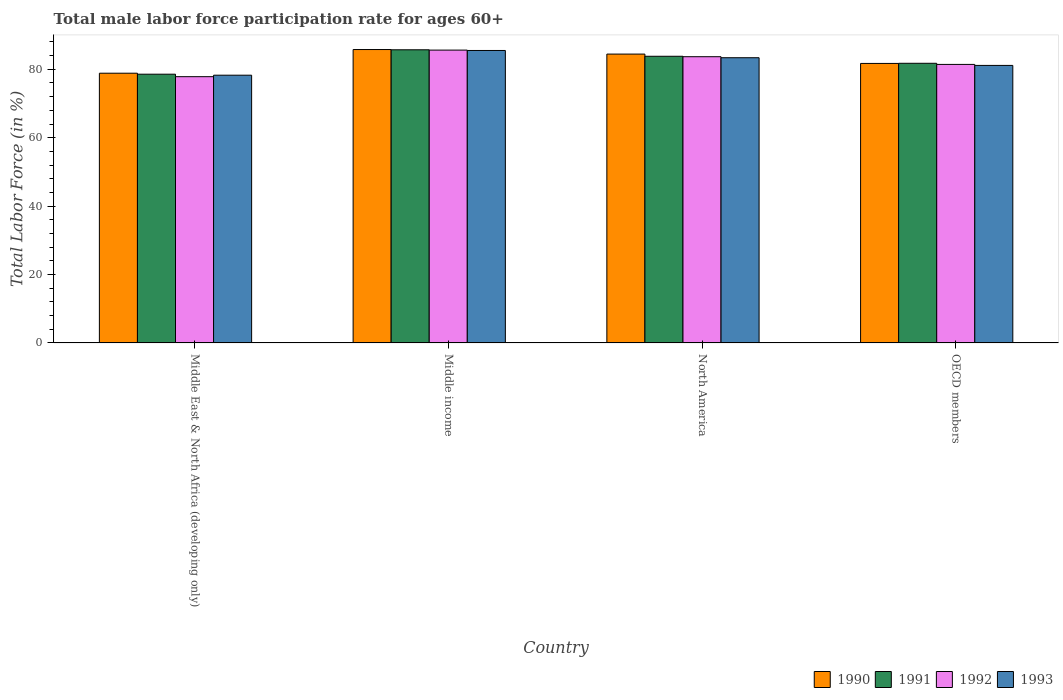How many different coloured bars are there?
Make the answer very short. 4. How many groups of bars are there?
Your answer should be compact. 4. Are the number of bars on each tick of the X-axis equal?
Give a very brief answer. Yes. How many bars are there on the 2nd tick from the left?
Give a very brief answer. 4. What is the male labor force participation rate in 1993 in Middle income?
Offer a terse response. 85.5. Across all countries, what is the maximum male labor force participation rate in 1990?
Keep it short and to the point. 85.78. Across all countries, what is the minimum male labor force participation rate in 1990?
Your answer should be very brief. 78.86. In which country was the male labor force participation rate in 1990 maximum?
Provide a short and direct response. Middle income. In which country was the male labor force participation rate in 1990 minimum?
Ensure brevity in your answer.  Middle East & North Africa (developing only). What is the total male labor force participation rate in 1993 in the graph?
Keep it short and to the point. 328.31. What is the difference between the male labor force participation rate in 1990 in Middle income and that in OECD members?
Your answer should be very brief. 4.06. What is the difference between the male labor force participation rate in 1990 in North America and the male labor force participation rate in 1992 in Middle East & North Africa (developing only)?
Your answer should be compact. 6.61. What is the average male labor force participation rate in 1992 per country?
Your response must be concise. 82.14. What is the difference between the male labor force participation rate of/in 1991 and male labor force participation rate of/in 1993 in North America?
Provide a short and direct response. 0.42. What is the ratio of the male labor force participation rate in 1990 in Middle income to that in OECD members?
Your answer should be compact. 1.05. What is the difference between the highest and the second highest male labor force participation rate in 1990?
Your answer should be compact. -2.73. What is the difference between the highest and the lowest male labor force participation rate in 1992?
Offer a terse response. 7.77. Is the sum of the male labor force participation rate in 1990 in North America and OECD members greater than the maximum male labor force participation rate in 1992 across all countries?
Give a very brief answer. Yes. How many bars are there?
Ensure brevity in your answer.  16. How many countries are there in the graph?
Offer a terse response. 4. What is the difference between two consecutive major ticks on the Y-axis?
Your answer should be compact. 20. Are the values on the major ticks of Y-axis written in scientific E-notation?
Offer a very short reply. No. Does the graph contain any zero values?
Your answer should be compact. No. Where does the legend appear in the graph?
Your response must be concise. Bottom right. How many legend labels are there?
Make the answer very short. 4. How are the legend labels stacked?
Your response must be concise. Horizontal. What is the title of the graph?
Your answer should be very brief. Total male labor force participation rate for ages 60+. What is the Total Labor Force (in %) in 1990 in Middle East & North Africa (developing only)?
Your answer should be very brief. 78.86. What is the Total Labor Force (in %) of 1991 in Middle East & North Africa (developing only)?
Offer a very short reply. 78.57. What is the Total Labor Force (in %) of 1992 in Middle East & North Africa (developing only)?
Provide a succinct answer. 77.85. What is the Total Labor Force (in %) of 1993 in Middle East & North Africa (developing only)?
Offer a very short reply. 78.28. What is the Total Labor Force (in %) in 1990 in Middle income?
Your answer should be very brief. 85.78. What is the Total Labor Force (in %) in 1991 in Middle income?
Give a very brief answer. 85.71. What is the Total Labor Force (in %) of 1992 in Middle income?
Offer a terse response. 85.62. What is the Total Labor Force (in %) in 1993 in Middle income?
Your answer should be compact. 85.5. What is the Total Labor Force (in %) in 1990 in North America?
Give a very brief answer. 84.45. What is the Total Labor Force (in %) of 1991 in North America?
Make the answer very short. 83.81. What is the Total Labor Force (in %) in 1992 in North America?
Offer a terse response. 83.69. What is the Total Labor Force (in %) of 1993 in North America?
Your answer should be very brief. 83.39. What is the Total Labor Force (in %) of 1990 in OECD members?
Provide a succinct answer. 81.72. What is the Total Labor Force (in %) in 1991 in OECD members?
Provide a succinct answer. 81.76. What is the Total Labor Force (in %) of 1992 in OECD members?
Ensure brevity in your answer.  81.43. What is the Total Labor Force (in %) in 1993 in OECD members?
Provide a succinct answer. 81.14. Across all countries, what is the maximum Total Labor Force (in %) in 1990?
Your answer should be compact. 85.78. Across all countries, what is the maximum Total Labor Force (in %) in 1991?
Your response must be concise. 85.71. Across all countries, what is the maximum Total Labor Force (in %) of 1992?
Your answer should be very brief. 85.62. Across all countries, what is the maximum Total Labor Force (in %) in 1993?
Your answer should be very brief. 85.5. Across all countries, what is the minimum Total Labor Force (in %) of 1990?
Offer a very short reply. 78.86. Across all countries, what is the minimum Total Labor Force (in %) in 1991?
Offer a terse response. 78.57. Across all countries, what is the minimum Total Labor Force (in %) in 1992?
Your response must be concise. 77.85. Across all countries, what is the minimum Total Labor Force (in %) of 1993?
Your response must be concise. 78.28. What is the total Total Labor Force (in %) in 1990 in the graph?
Provide a short and direct response. 330.81. What is the total Total Labor Force (in %) in 1991 in the graph?
Provide a short and direct response. 329.85. What is the total Total Labor Force (in %) of 1992 in the graph?
Your answer should be very brief. 328.58. What is the total Total Labor Force (in %) of 1993 in the graph?
Give a very brief answer. 328.31. What is the difference between the Total Labor Force (in %) of 1990 in Middle East & North Africa (developing only) and that in Middle income?
Your answer should be compact. -6.92. What is the difference between the Total Labor Force (in %) in 1991 in Middle East & North Africa (developing only) and that in Middle income?
Provide a succinct answer. -7.13. What is the difference between the Total Labor Force (in %) in 1992 in Middle East & North Africa (developing only) and that in Middle income?
Provide a short and direct response. -7.77. What is the difference between the Total Labor Force (in %) in 1993 in Middle East & North Africa (developing only) and that in Middle income?
Provide a succinct answer. -7.23. What is the difference between the Total Labor Force (in %) of 1990 in Middle East & North Africa (developing only) and that in North America?
Offer a very short reply. -5.59. What is the difference between the Total Labor Force (in %) in 1991 in Middle East & North Africa (developing only) and that in North America?
Your response must be concise. -5.24. What is the difference between the Total Labor Force (in %) in 1992 in Middle East & North Africa (developing only) and that in North America?
Your answer should be very brief. -5.84. What is the difference between the Total Labor Force (in %) of 1993 in Middle East & North Africa (developing only) and that in North America?
Provide a succinct answer. -5.11. What is the difference between the Total Labor Force (in %) of 1990 in Middle East & North Africa (developing only) and that in OECD members?
Offer a very short reply. -2.86. What is the difference between the Total Labor Force (in %) in 1991 in Middle East & North Africa (developing only) and that in OECD members?
Keep it short and to the point. -3.19. What is the difference between the Total Labor Force (in %) of 1992 in Middle East & North Africa (developing only) and that in OECD members?
Give a very brief answer. -3.58. What is the difference between the Total Labor Force (in %) in 1993 in Middle East & North Africa (developing only) and that in OECD members?
Provide a short and direct response. -2.86. What is the difference between the Total Labor Force (in %) of 1990 in Middle income and that in North America?
Your response must be concise. 1.33. What is the difference between the Total Labor Force (in %) in 1991 in Middle income and that in North America?
Your answer should be compact. 1.9. What is the difference between the Total Labor Force (in %) in 1992 in Middle income and that in North America?
Your answer should be very brief. 1.93. What is the difference between the Total Labor Force (in %) in 1993 in Middle income and that in North America?
Make the answer very short. 2.12. What is the difference between the Total Labor Force (in %) in 1990 in Middle income and that in OECD members?
Keep it short and to the point. 4.06. What is the difference between the Total Labor Force (in %) of 1991 in Middle income and that in OECD members?
Make the answer very short. 3.95. What is the difference between the Total Labor Force (in %) in 1992 in Middle income and that in OECD members?
Provide a succinct answer. 4.19. What is the difference between the Total Labor Force (in %) of 1993 in Middle income and that in OECD members?
Ensure brevity in your answer.  4.36. What is the difference between the Total Labor Force (in %) in 1990 in North America and that in OECD members?
Your answer should be very brief. 2.73. What is the difference between the Total Labor Force (in %) in 1991 in North America and that in OECD members?
Your response must be concise. 2.05. What is the difference between the Total Labor Force (in %) in 1992 in North America and that in OECD members?
Ensure brevity in your answer.  2.26. What is the difference between the Total Labor Force (in %) in 1993 in North America and that in OECD members?
Provide a succinct answer. 2.25. What is the difference between the Total Labor Force (in %) of 1990 in Middle East & North Africa (developing only) and the Total Labor Force (in %) of 1991 in Middle income?
Ensure brevity in your answer.  -6.85. What is the difference between the Total Labor Force (in %) of 1990 in Middle East & North Africa (developing only) and the Total Labor Force (in %) of 1992 in Middle income?
Provide a succinct answer. -6.76. What is the difference between the Total Labor Force (in %) of 1990 in Middle East & North Africa (developing only) and the Total Labor Force (in %) of 1993 in Middle income?
Your answer should be compact. -6.65. What is the difference between the Total Labor Force (in %) in 1991 in Middle East & North Africa (developing only) and the Total Labor Force (in %) in 1992 in Middle income?
Offer a terse response. -7.04. What is the difference between the Total Labor Force (in %) in 1991 in Middle East & North Africa (developing only) and the Total Labor Force (in %) in 1993 in Middle income?
Provide a short and direct response. -6.93. What is the difference between the Total Labor Force (in %) of 1992 in Middle East & North Africa (developing only) and the Total Labor Force (in %) of 1993 in Middle income?
Keep it short and to the point. -7.66. What is the difference between the Total Labor Force (in %) in 1990 in Middle East & North Africa (developing only) and the Total Labor Force (in %) in 1991 in North America?
Offer a very short reply. -4.95. What is the difference between the Total Labor Force (in %) in 1990 in Middle East & North Africa (developing only) and the Total Labor Force (in %) in 1992 in North America?
Provide a short and direct response. -4.83. What is the difference between the Total Labor Force (in %) in 1990 in Middle East & North Africa (developing only) and the Total Labor Force (in %) in 1993 in North America?
Offer a very short reply. -4.53. What is the difference between the Total Labor Force (in %) in 1991 in Middle East & North Africa (developing only) and the Total Labor Force (in %) in 1992 in North America?
Provide a succinct answer. -5.11. What is the difference between the Total Labor Force (in %) in 1991 in Middle East & North Africa (developing only) and the Total Labor Force (in %) in 1993 in North America?
Ensure brevity in your answer.  -4.81. What is the difference between the Total Labor Force (in %) of 1992 in Middle East & North Africa (developing only) and the Total Labor Force (in %) of 1993 in North America?
Ensure brevity in your answer.  -5.54. What is the difference between the Total Labor Force (in %) of 1990 in Middle East & North Africa (developing only) and the Total Labor Force (in %) of 1991 in OECD members?
Your answer should be compact. -2.9. What is the difference between the Total Labor Force (in %) of 1990 in Middle East & North Africa (developing only) and the Total Labor Force (in %) of 1992 in OECD members?
Keep it short and to the point. -2.57. What is the difference between the Total Labor Force (in %) in 1990 in Middle East & North Africa (developing only) and the Total Labor Force (in %) in 1993 in OECD members?
Your response must be concise. -2.28. What is the difference between the Total Labor Force (in %) of 1991 in Middle East & North Africa (developing only) and the Total Labor Force (in %) of 1992 in OECD members?
Provide a succinct answer. -2.86. What is the difference between the Total Labor Force (in %) in 1991 in Middle East & North Africa (developing only) and the Total Labor Force (in %) in 1993 in OECD members?
Ensure brevity in your answer.  -2.57. What is the difference between the Total Labor Force (in %) in 1992 in Middle East & North Africa (developing only) and the Total Labor Force (in %) in 1993 in OECD members?
Provide a short and direct response. -3.3. What is the difference between the Total Labor Force (in %) in 1990 in Middle income and the Total Labor Force (in %) in 1991 in North America?
Offer a very short reply. 1.97. What is the difference between the Total Labor Force (in %) of 1990 in Middle income and the Total Labor Force (in %) of 1992 in North America?
Make the answer very short. 2.09. What is the difference between the Total Labor Force (in %) of 1990 in Middle income and the Total Labor Force (in %) of 1993 in North America?
Your answer should be very brief. 2.39. What is the difference between the Total Labor Force (in %) in 1991 in Middle income and the Total Labor Force (in %) in 1992 in North America?
Provide a succinct answer. 2.02. What is the difference between the Total Labor Force (in %) in 1991 in Middle income and the Total Labor Force (in %) in 1993 in North America?
Offer a very short reply. 2.32. What is the difference between the Total Labor Force (in %) of 1992 in Middle income and the Total Labor Force (in %) of 1993 in North America?
Your answer should be very brief. 2.23. What is the difference between the Total Labor Force (in %) of 1990 in Middle income and the Total Labor Force (in %) of 1991 in OECD members?
Offer a terse response. 4.02. What is the difference between the Total Labor Force (in %) of 1990 in Middle income and the Total Labor Force (in %) of 1992 in OECD members?
Your answer should be compact. 4.35. What is the difference between the Total Labor Force (in %) of 1990 in Middle income and the Total Labor Force (in %) of 1993 in OECD members?
Offer a terse response. 4.64. What is the difference between the Total Labor Force (in %) in 1991 in Middle income and the Total Labor Force (in %) in 1992 in OECD members?
Make the answer very short. 4.28. What is the difference between the Total Labor Force (in %) in 1991 in Middle income and the Total Labor Force (in %) in 1993 in OECD members?
Keep it short and to the point. 4.57. What is the difference between the Total Labor Force (in %) in 1992 in Middle income and the Total Labor Force (in %) in 1993 in OECD members?
Provide a short and direct response. 4.48. What is the difference between the Total Labor Force (in %) in 1990 in North America and the Total Labor Force (in %) in 1991 in OECD members?
Your response must be concise. 2.69. What is the difference between the Total Labor Force (in %) in 1990 in North America and the Total Labor Force (in %) in 1992 in OECD members?
Provide a short and direct response. 3.02. What is the difference between the Total Labor Force (in %) in 1990 in North America and the Total Labor Force (in %) in 1993 in OECD members?
Offer a very short reply. 3.31. What is the difference between the Total Labor Force (in %) in 1991 in North America and the Total Labor Force (in %) in 1992 in OECD members?
Keep it short and to the point. 2.38. What is the difference between the Total Labor Force (in %) in 1991 in North America and the Total Labor Force (in %) in 1993 in OECD members?
Ensure brevity in your answer.  2.67. What is the difference between the Total Labor Force (in %) of 1992 in North America and the Total Labor Force (in %) of 1993 in OECD members?
Give a very brief answer. 2.54. What is the average Total Labor Force (in %) in 1990 per country?
Provide a succinct answer. 82.7. What is the average Total Labor Force (in %) in 1991 per country?
Your answer should be compact. 82.46. What is the average Total Labor Force (in %) in 1992 per country?
Your answer should be compact. 82.14. What is the average Total Labor Force (in %) of 1993 per country?
Provide a succinct answer. 82.08. What is the difference between the Total Labor Force (in %) of 1990 and Total Labor Force (in %) of 1991 in Middle East & North Africa (developing only)?
Offer a terse response. 0.29. What is the difference between the Total Labor Force (in %) of 1990 and Total Labor Force (in %) of 1992 in Middle East & North Africa (developing only)?
Your response must be concise. 1.01. What is the difference between the Total Labor Force (in %) in 1990 and Total Labor Force (in %) in 1993 in Middle East & North Africa (developing only)?
Your response must be concise. 0.58. What is the difference between the Total Labor Force (in %) in 1991 and Total Labor Force (in %) in 1992 in Middle East & North Africa (developing only)?
Give a very brief answer. 0.73. What is the difference between the Total Labor Force (in %) in 1991 and Total Labor Force (in %) in 1993 in Middle East & North Africa (developing only)?
Offer a terse response. 0.29. What is the difference between the Total Labor Force (in %) of 1992 and Total Labor Force (in %) of 1993 in Middle East & North Africa (developing only)?
Offer a terse response. -0.43. What is the difference between the Total Labor Force (in %) in 1990 and Total Labor Force (in %) in 1991 in Middle income?
Provide a short and direct response. 0.07. What is the difference between the Total Labor Force (in %) in 1990 and Total Labor Force (in %) in 1992 in Middle income?
Your answer should be very brief. 0.16. What is the difference between the Total Labor Force (in %) of 1990 and Total Labor Force (in %) of 1993 in Middle income?
Keep it short and to the point. 0.27. What is the difference between the Total Labor Force (in %) in 1991 and Total Labor Force (in %) in 1992 in Middle income?
Your answer should be very brief. 0.09. What is the difference between the Total Labor Force (in %) of 1991 and Total Labor Force (in %) of 1993 in Middle income?
Make the answer very short. 0.2. What is the difference between the Total Labor Force (in %) in 1992 and Total Labor Force (in %) in 1993 in Middle income?
Offer a terse response. 0.11. What is the difference between the Total Labor Force (in %) in 1990 and Total Labor Force (in %) in 1991 in North America?
Keep it short and to the point. 0.64. What is the difference between the Total Labor Force (in %) of 1990 and Total Labor Force (in %) of 1992 in North America?
Your answer should be compact. 0.77. What is the difference between the Total Labor Force (in %) in 1990 and Total Labor Force (in %) in 1993 in North America?
Ensure brevity in your answer.  1.07. What is the difference between the Total Labor Force (in %) in 1991 and Total Labor Force (in %) in 1992 in North America?
Provide a succinct answer. 0.12. What is the difference between the Total Labor Force (in %) in 1991 and Total Labor Force (in %) in 1993 in North America?
Ensure brevity in your answer.  0.42. What is the difference between the Total Labor Force (in %) in 1992 and Total Labor Force (in %) in 1993 in North America?
Offer a terse response. 0.3. What is the difference between the Total Labor Force (in %) in 1990 and Total Labor Force (in %) in 1991 in OECD members?
Offer a very short reply. -0.04. What is the difference between the Total Labor Force (in %) of 1990 and Total Labor Force (in %) of 1992 in OECD members?
Keep it short and to the point. 0.29. What is the difference between the Total Labor Force (in %) of 1990 and Total Labor Force (in %) of 1993 in OECD members?
Make the answer very short. 0.58. What is the difference between the Total Labor Force (in %) in 1991 and Total Labor Force (in %) in 1992 in OECD members?
Your answer should be compact. 0.33. What is the difference between the Total Labor Force (in %) of 1991 and Total Labor Force (in %) of 1993 in OECD members?
Your answer should be very brief. 0.62. What is the difference between the Total Labor Force (in %) in 1992 and Total Labor Force (in %) in 1993 in OECD members?
Provide a short and direct response. 0.29. What is the ratio of the Total Labor Force (in %) of 1990 in Middle East & North Africa (developing only) to that in Middle income?
Keep it short and to the point. 0.92. What is the ratio of the Total Labor Force (in %) in 1991 in Middle East & North Africa (developing only) to that in Middle income?
Offer a terse response. 0.92. What is the ratio of the Total Labor Force (in %) of 1992 in Middle East & North Africa (developing only) to that in Middle income?
Ensure brevity in your answer.  0.91. What is the ratio of the Total Labor Force (in %) in 1993 in Middle East & North Africa (developing only) to that in Middle income?
Your answer should be compact. 0.92. What is the ratio of the Total Labor Force (in %) of 1990 in Middle East & North Africa (developing only) to that in North America?
Give a very brief answer. 0.93. What is the ratio of the Total Labor Force (in %) of 1992 in Middle East & North Africa (developing only) to that in North America?
Make the answer very short. 0.93. What is the ratio of the Total Labor Force (in %) in 1993 in Middle East & North Africa (developing only) to that in North America?
Offer a terse response. 0.94. What is the ratio of the Total Labor Force (in %) in 1991 in Middle East & North Africa (developing only) to that in OECD members?
Provide a short and direct response. 0.96. What is the ratio of the Total Labor Force (in %) in 1992 in Middle East & North Africa (developing only) to that in OECD members?
Your answer should be compact. 0.96. What is the ratio of the Total Labor Force (in %) in 1993 in Middle East & North Africa (developing only) to that in OECD members?
Offer a terse response. 0.96. What is the ratio of the Total Labor Force (in %) in 1990 in Middle income to that in North America?
Your answer should be compact. 1.02. What is the ratio of the Total Labor Force (in %) in 1991 in Middle income to that in North America?
Provide a succinct answer. 1.02. What is the ratio of the Total Labor Force (in %) of 1992 in Middle income to that in North America?
Offer a terse response. 1.02. What is the ratio of the Total Labor Force (in %) of 1993 in Middle income to that in North America?
Offer a very short reply. 1.03. What is the ratio of the Total Labor Force (in %) of 1990 in Middle income to that in OECD members?
Your answer should be compact. 1.05. What is the ratio of the Total Labor Force (in %) in 1991 in Middle income to that in OECD members?
Provide a succinct answer. 1.05. What is the ratio of the Total Labor Force (in %) in 1992 in Middle income to that in OECD members?
Your answer should be compact. 1.05. What is the ratio of the Total Labor Force (in %) in 1993 in Middle income to that in OECD members?
Provide a succinct answer. 1.05. What is the ratio of the Total Labor Force (in %) in 1990 in North America to that in OECD members?
Provide a succinct answer. 1.03. What is the ratio of the Total Labor Force (in %) of 1991 in North America to that in OECD members?
Give a very brief answer. 1.03. What is the ratio of the Total Labor Force (in %) in 1992 in North America to that in OECD members?
Your answer should be compact. 1.03. What is the ratio of the Total Labor Force (in %) of 1993 in North America to that in OECD members?
Your answer should be compact. 1.03. What is the difference between the highest and the second highest Total Labor Force (in %) in 1990?
Provide a succinct answer. 1.33. What is the difference between the highest and the second highest Total Labor Force (in %) in 1991?
Make the answer very short. 1.9. What is the difference between the highest and the second highest Total Labor Force (in %) in 1992?
Offer a terse response. 1.93. What is the difference between the highest and the second highest Total Labor Force (in %) of 1993?
Your answer should be very brief. 2.12. What is the difference between the highest and the lowest Total Labor Force (in %) in 1990?
Your response must be concise. 6.92. What is the difference between the highest and the lowest Total Labor Force (in %) of 1991?
Your response must be concise. 7.13. What is the difference between the highest and the lowest Total Labor Force (in %) of 1992?
Your response must be concise. 7.77. What is the difference between the highest and the lowest Total Labor Force (in %) of 1993?
Ensure brevity in your answer.  7.23. 